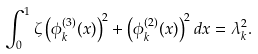Convert formula to latex. <formula><loc_0><loc_0><loc_500><loc_500>\int _ { 0 } ^ { 1 } { \zeta \left ( \phi _ { k } ^ { ( 3 ) } ( x ) \right ) ^ { 2 } + \left ( \phi _ { k } ^ { ( 2 ) } ( x ) \right ) ^ { 2 } d x } = \lambda _ { k } ^ { 2 } .</formula> 